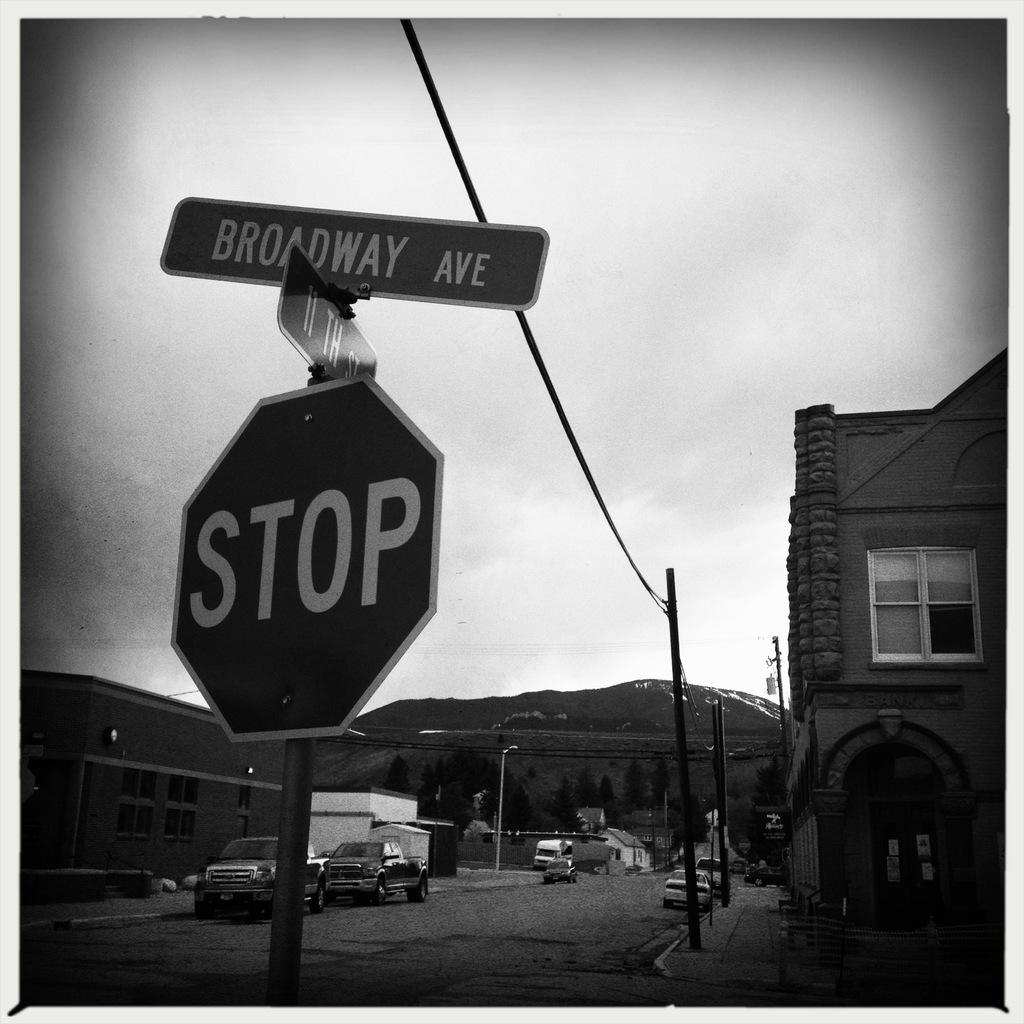<image>
Offer a succinct explanation of the picture presented. a stop sign that is outside on the ground with many items around 